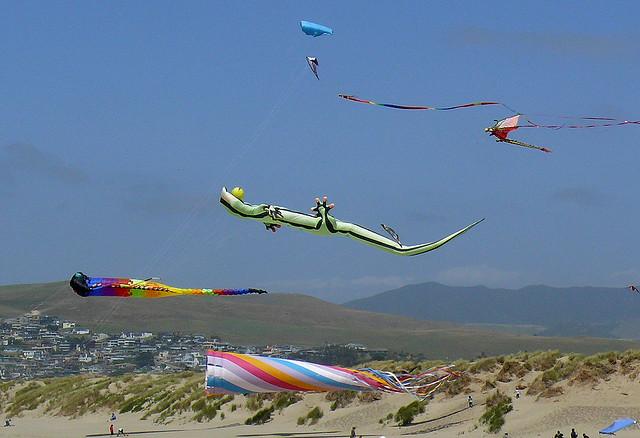Is the weather sunny?
Write a very short answer. Yes. How many kites are in the sky?
Be succinct. 6. What type of art is shown?
Quick response, please. Kites. Which kit seem highest?
Quick response, please. Blue. 